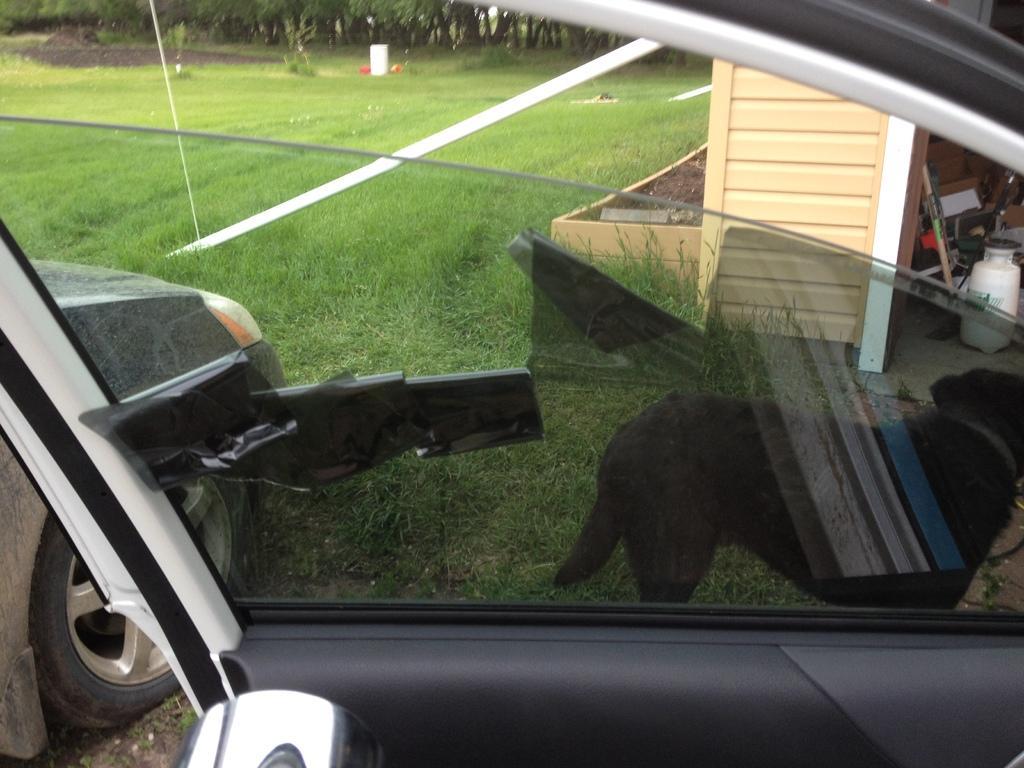Can you describe this image briefly? In this image we can see there is a door and a window of a vehicle, through the window we can see there is another car, a dog, a few objects in the wooden house and few object on the surface of the grass. In the background there are trees. 